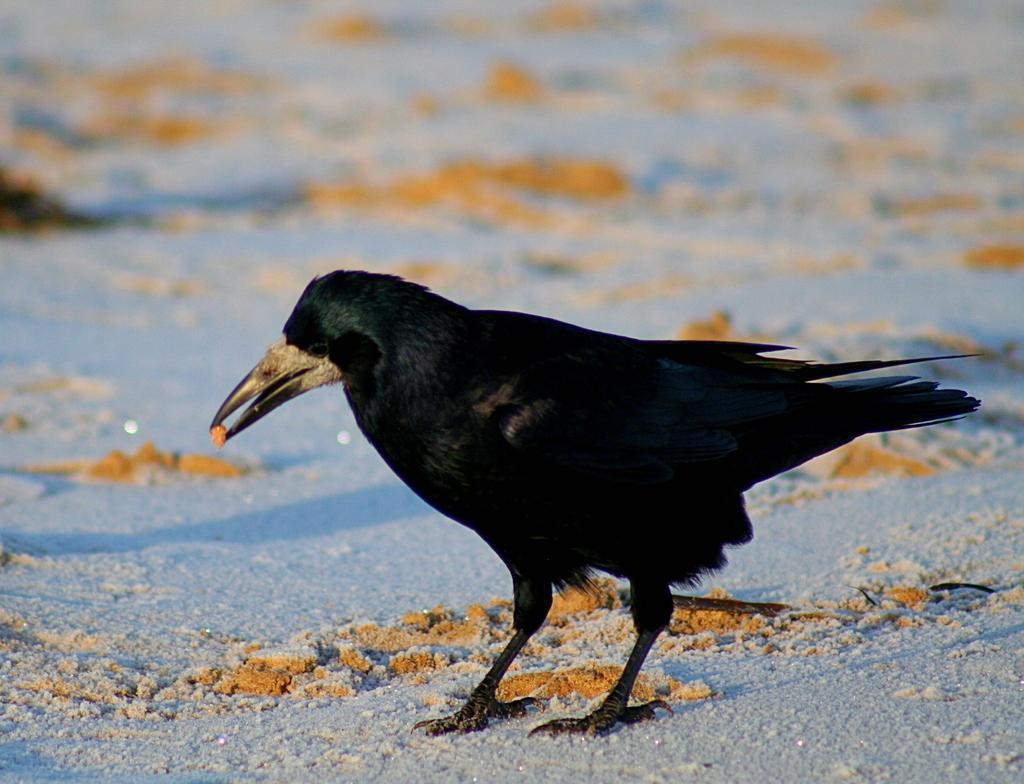What type of bird is in the image? There is a black crow in the image. Where is the crow located? The crow is standing on a path. What is the crow holding in its beak? The crow is holding an orange object in its beak. Can you describe the background of the image? The background of the image is blurry. What type of office supplies can be seen on the crow's desk in the image? There is no desk or office supplies present in the image; it features a black crow standing on a path and holding an orange object in its beak. 